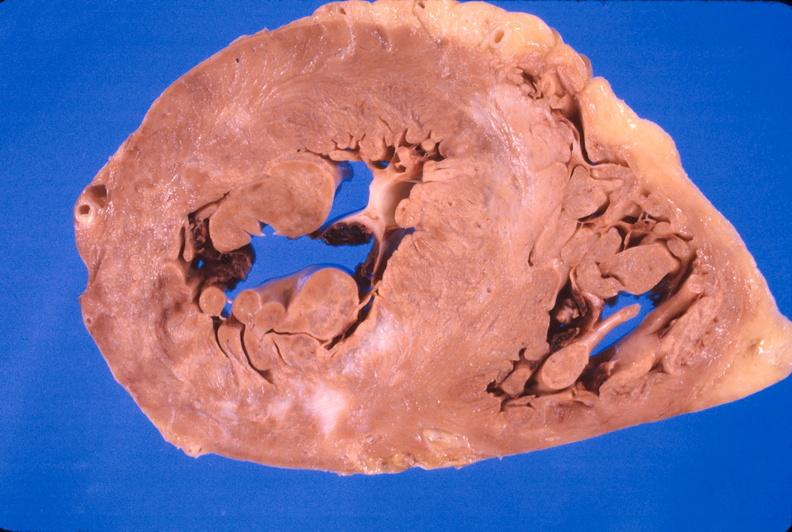what does this image show?
Answer the question using a single word or phrase. Heart 